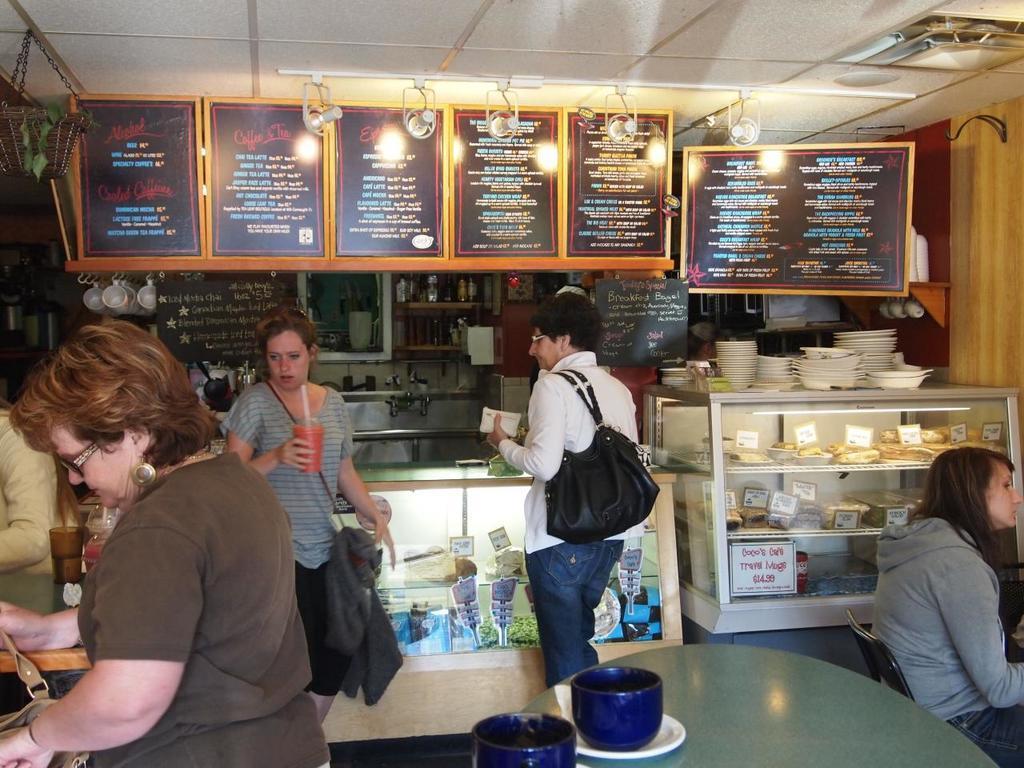How would you summarize this image in a sentence or two? Few people are standing and a woman is sitting in a coffee shop. 